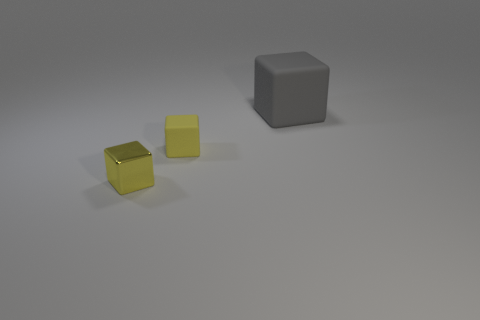Subtract all yellow cylinders. How many yellow cubes are left? 2 Subtract all tiny blocks. How many blocks are left? 1 Subtract 1 blocks. How many blocks are left? 2 Add 3 yellow balls. How many objects exist? 6 Subtract all brown cubes. Subtract all red spheres. How many cubes are left? 3 Add 3 cyan shiny cylinders. How many cyan shiny cylinders exist? 3 Subtract 0 blue spheres. How many objects are left? 3 Subtract all tiny rubber blocks. Subtract all large green rubber balls. How many objects are left? 2 Add 1 gray matte things. How many gray matte things are left? 2 